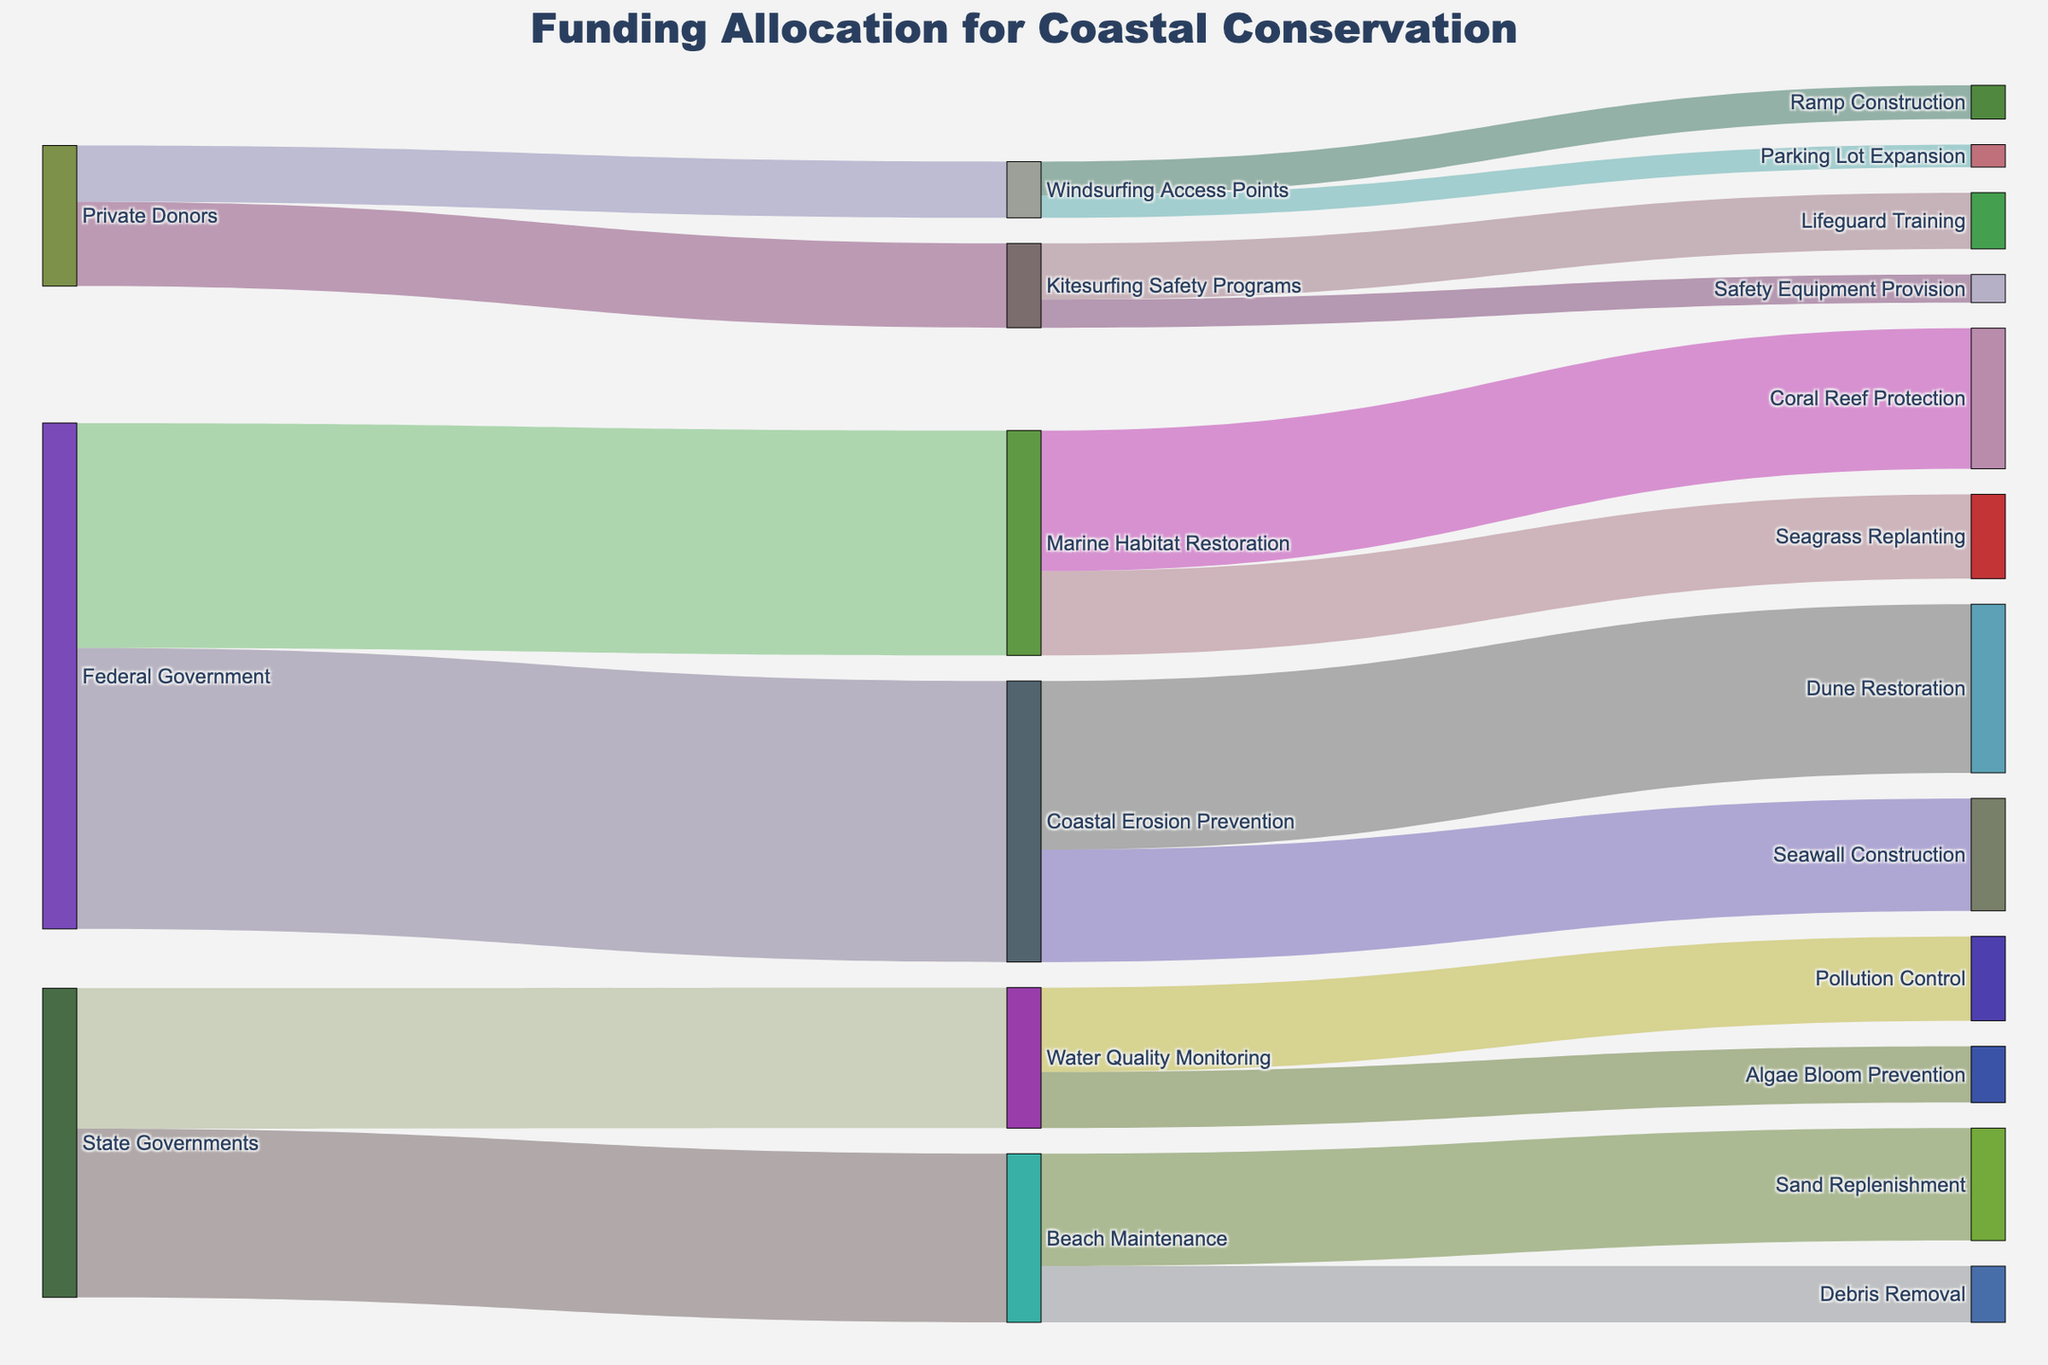How much funding did the Federal Government allocate to Marine Habitat Restoration? Identify the node "Federal Government" and follow the link connecting to "Marine Habitat Restoration." The value associated with this link is 4,000,000.
Answer: 4,000,000 Which funding source allocated the most towards Beach Maintenance? Identify the node "Beach Maintenance" and follow the links connecting to the sources. The "State Governments" node allocates 3,000,000, which is the highest amount.
Answer: State Governments How much total funding was allocated by the Federal Government? Identify the "Federal Government" node and sum the values of links coming out of it (5,000,000 for Coastal Erosion Prevention + 4,000,000 for Marine Habitat Restoration).
Answer: 9,000,000 Compare the funding allocated to Kitesurfing Safety Programs and Windsurfing Access Points by Private Donors. Which one got more, and by how much? Find the links from "Private Donors" to "Kitesurfing Safety Programs" and "Windsurfing Access Points." Kitesurfing Safety Programs received 1,500,000, while Windsurfing Access Points got 1,000,000. The difference is 1,500,000 - 1,000,000.
Answer: Kitesurfing Safety Programs received 500,000 more What percentage of the total funding from the Federal Government was allocated to Coastal Erosion Prevention? Identify total funding from "Federal Government" is 9,000,000. The amount allocated to "Coastal Erosion Prevention" is 5,000,000. The percentage is (5,000,000 / 9,000,000) * 100.
Answer: 55.56% Which subcategory within Coastal Erosion Prevention received more funding: Dune Restoration or Seawall Construction? Find links from "Coastal Erosion Prevention" to its subcategories. Dune Restoration received 3,000,000, while Seawall Construction got 2,000,000.
Answer: Dune Restoration What is the total funding allocated for Water Quality Monitoring? Identify the "Water Quality Monitoring" node and sum the values of links connected to it (1,500,000 for Pollution Control + 1,000,000 for Algae Bloom Prevention).
Answer: 2,500,000 How much funding did Coral Reef Protection receive? Identify the "Coral Reef Protection" node and find the value of the link connected to it, which is 2,500,000.
Answer: 2,500,000 What is the combined funding from Private Donors for all initiatives? Identify the "Private Donors" node and sum the values of all links coming out of it (1,500,000 for Kitesurfing Safety Programs + 1,000,000 for Windsurfing Access Points).
Answer: 2,500,000 Identify the node that received the highest single allocation of funds. Compare the values of all outgoing links. "Federal Government" to "Coastal Erosion Prevention" with 5,000,000 is the highest single allocation.
Answer: Coastal Erosion Prevention 